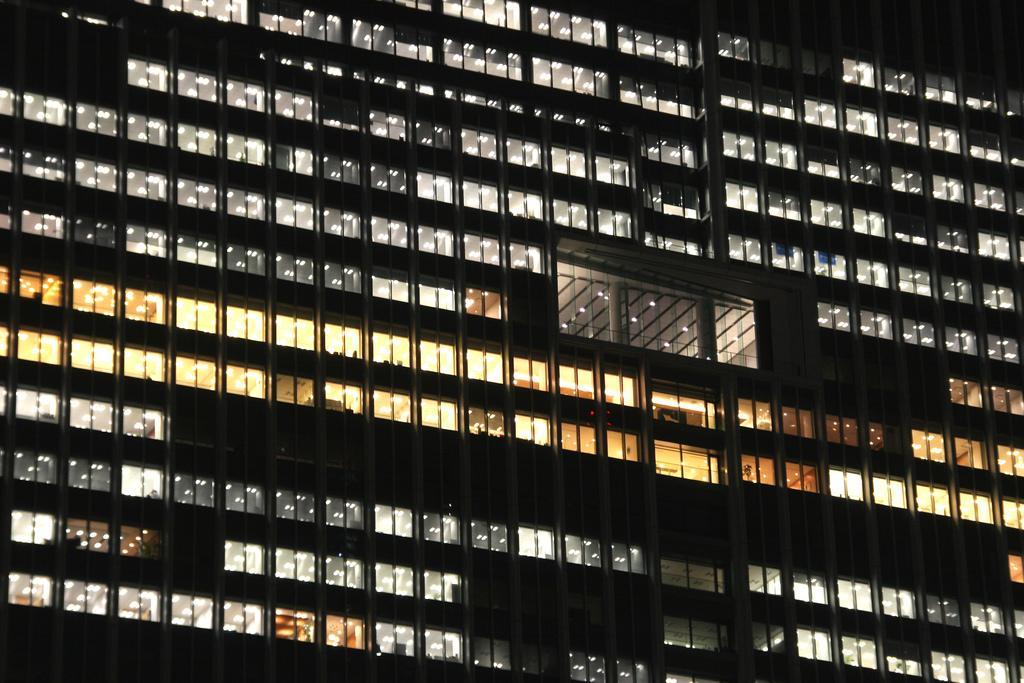Can you describe this image briefly? In this image I can see the building, few glass windows and I can also see few lights. 